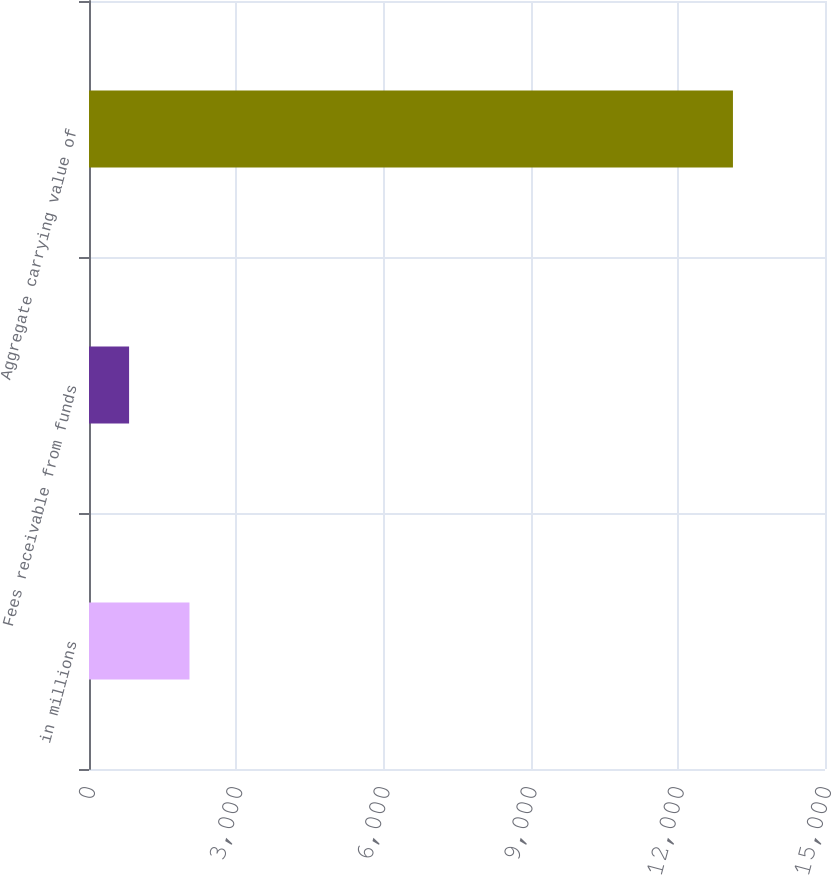<chart> <loc_0><loc_0><loc_500><loc_500><bar_chart><fcel>in millions<fcel>Fees receivable from funds<fcel>Aggregate carrying value of<nl><fcel>2047.7<fcel>817<fcel>13124<nl></chart> 